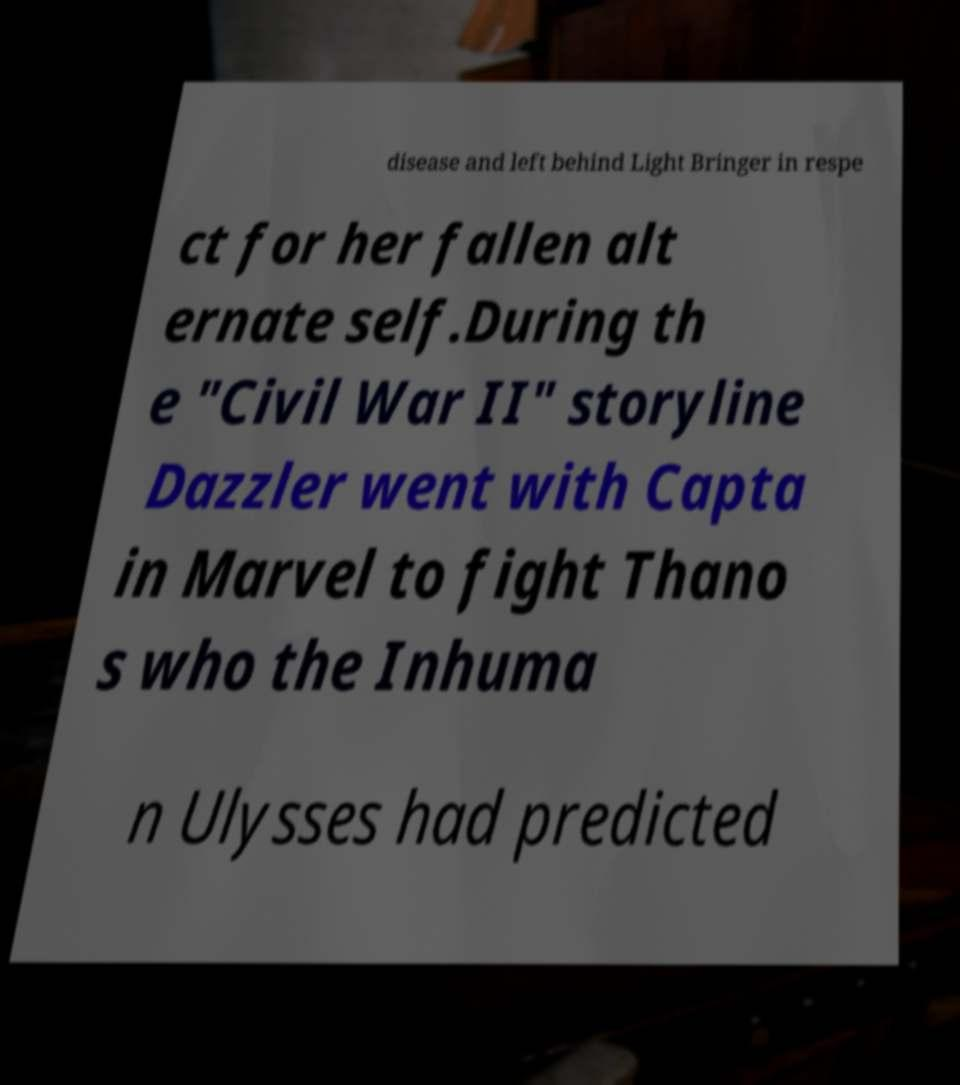Could you assist in decoding the text presented in this image and type it out clearly? disease and left behind Light Bringer in respe ct for her fallen alt ernate self.During th e "Civil War II" storyline Dazzler went with Capta in Marvel to fight Thano s who the Inhuma n Ulysses had predicted 